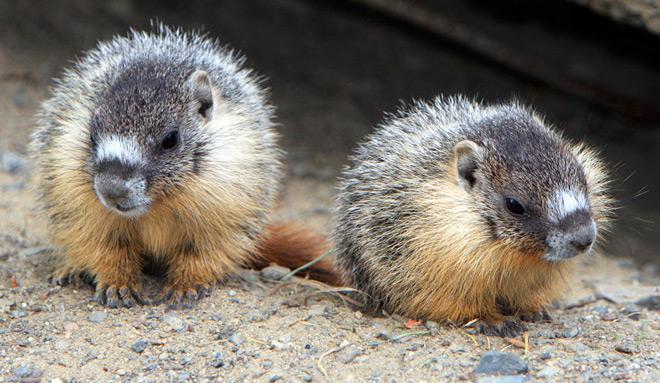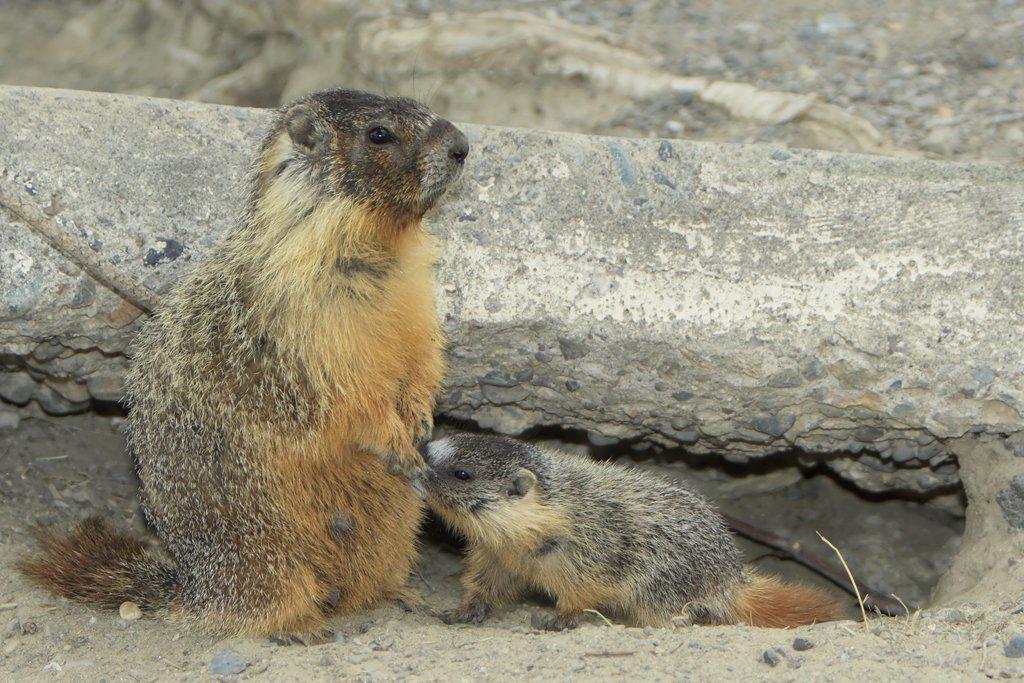The first image is the image on the left, the second image is the image on the right. Given the left and right images, does the statement "An image shows an upright rodent-type animal." hold true? Answer yes or no. Yes. 